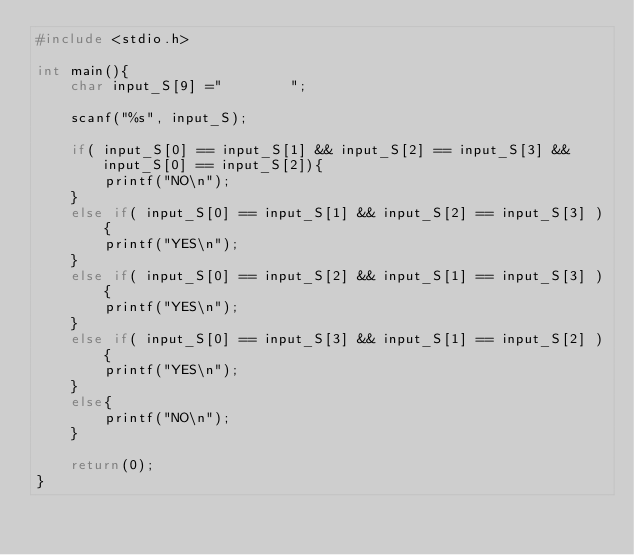<code> <loc_0><loc_0><loc_500><loc_500><_C++_>#include <stdio.h>

int main(){
    char input_S[9] ="        ";

    scanf("%s", input_S);

    if( input_S[0] == input_S[1] && input_S[2] == input_S[3] && input_S[0] == input_S[2]){
        printf("NO\n");
    }
    else if( input_S[0] == input_S[1] && input_S[2] == input_S[3] ){
        printf("YES\n");
    }
    else if( input_S[0] == input_S[2] && input_S[1] == input_S[3] ){
        printf("YES\n");
    }
    else if( input_S[0] == input_S[3] && input_S[1] == input_S[2] ){
        printf("YES\n");
    }
    else{
        printf("NO\n");
    }

    return(0);
}</code> 